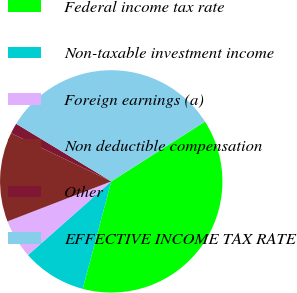Convert chart to OTSL. <chart><loc_0><loc_0><loc_500><loc_500><pie_chart><fcel>Federal income tax rate<fcel>Non-taxable investment income<fcel>Foreign earnings (a)<fcel>Non deductible compensation<fcel>Other<fcel>EFFECTIVE INCOME TAX RATE<nl><fcel>38.18%<fcel>9.34%<fcel>5.67%<fcel>13.0%<fcel>1.53%<fcel>32.29%<nl></chart> 